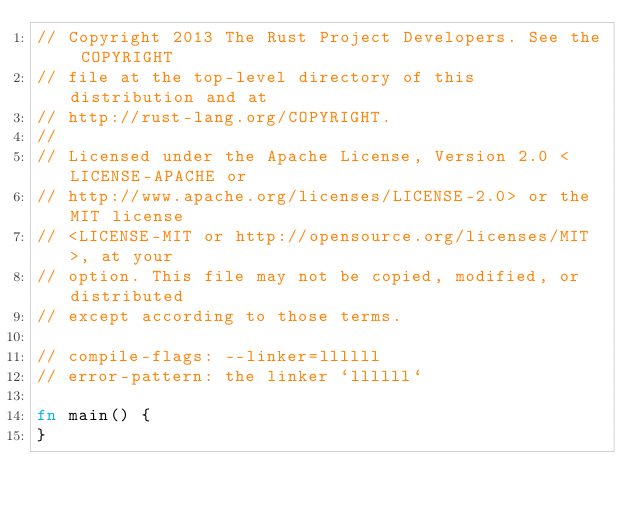<code> <loc_0><loc_0><loc_500><loc_500><_Rust_>// Copyright 2013 The Rust Project Developers. See the COPYRIGHT
// file at the top-level directory of this distribution and at
// http://rust-lang.org/COPYRIGHT.
//
// Licensed under the Apache License, Version 2.0 <LICENSE-APACHE or
// http://www.apache.org/licenses/LICENSE-2.0> or the MIT license
// <LICENSE-MIT or http://opensource.org/licenses/MIT>, at your
// option. This file may not be copied, modified, or distributed
// except according to those terms.

// compile-flags: --linker=llllll
// error-pattern: the linker `llllll`

fn main() {
}
</code> 